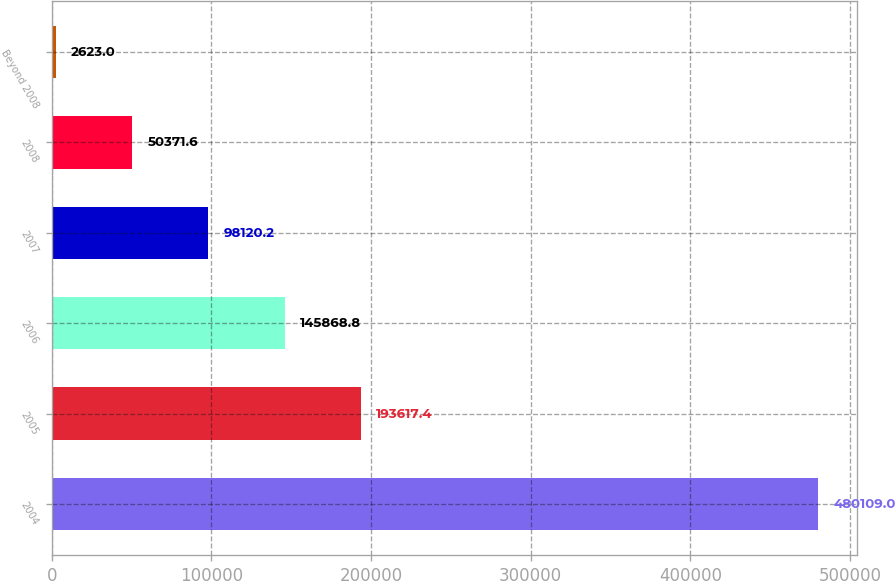<chart> <loc_0><loc_0><loc_500><loc_500><bar_chart><fcel>2004<fcel>2005<fcel>2006<fcel>2007<fcel>2008<fcel>Beyond 2008<nl><fcel>480109<fcel>193617<fcel>145869<fcel>98120.2<fcel>50371.6<fcel>2623<nl></chart> 